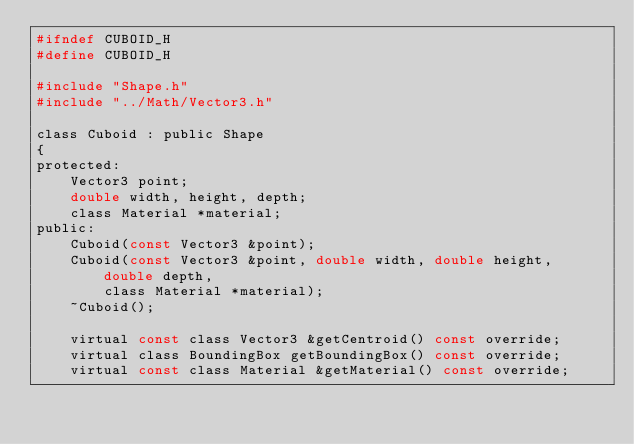<code> <loc_0><loc_0><loc_500><loc_500><_C_>#ifndef CUBOID_H
#define CUBOID_H

#include "Shape.h"
#include "../Math/Vector3.h"

class Cuboid : public Shape
{
protected:
	Vector3 point;
	double width, height, depth;
	class Material *material;
public:
	Cuboid(const Vector3 &point);
	Cuboid(const Vector3 &point, double width, double height, double depth,
		class Material *material);
	~Cuboid();

	virtual const class Vector3 &getCentroid() const override;
	virtual class BoundingBox getBoundingBox() const override;
	virtual const class Material &getMaterial() const override;</code> 